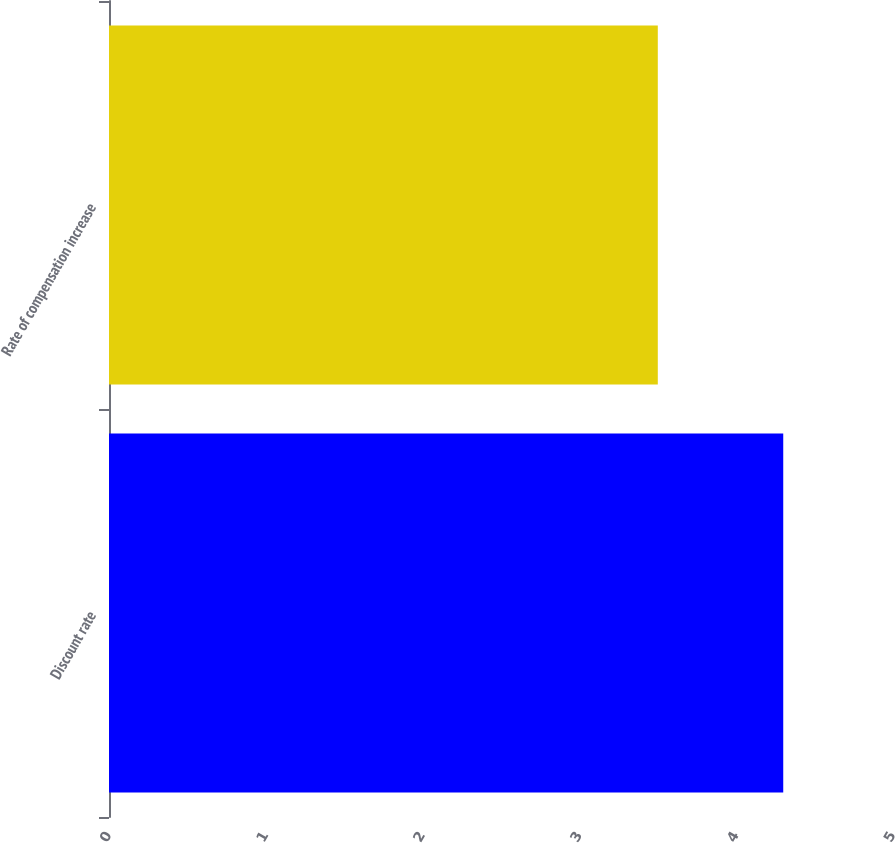Convert chart. <chart><loc_0><loc_0><loc_500><loc_500><bar_chart><fcel>Discount rate<fcel>Rate of compensation increase<nl><fcel>4.3<fcel>3.5<nl></chart> 